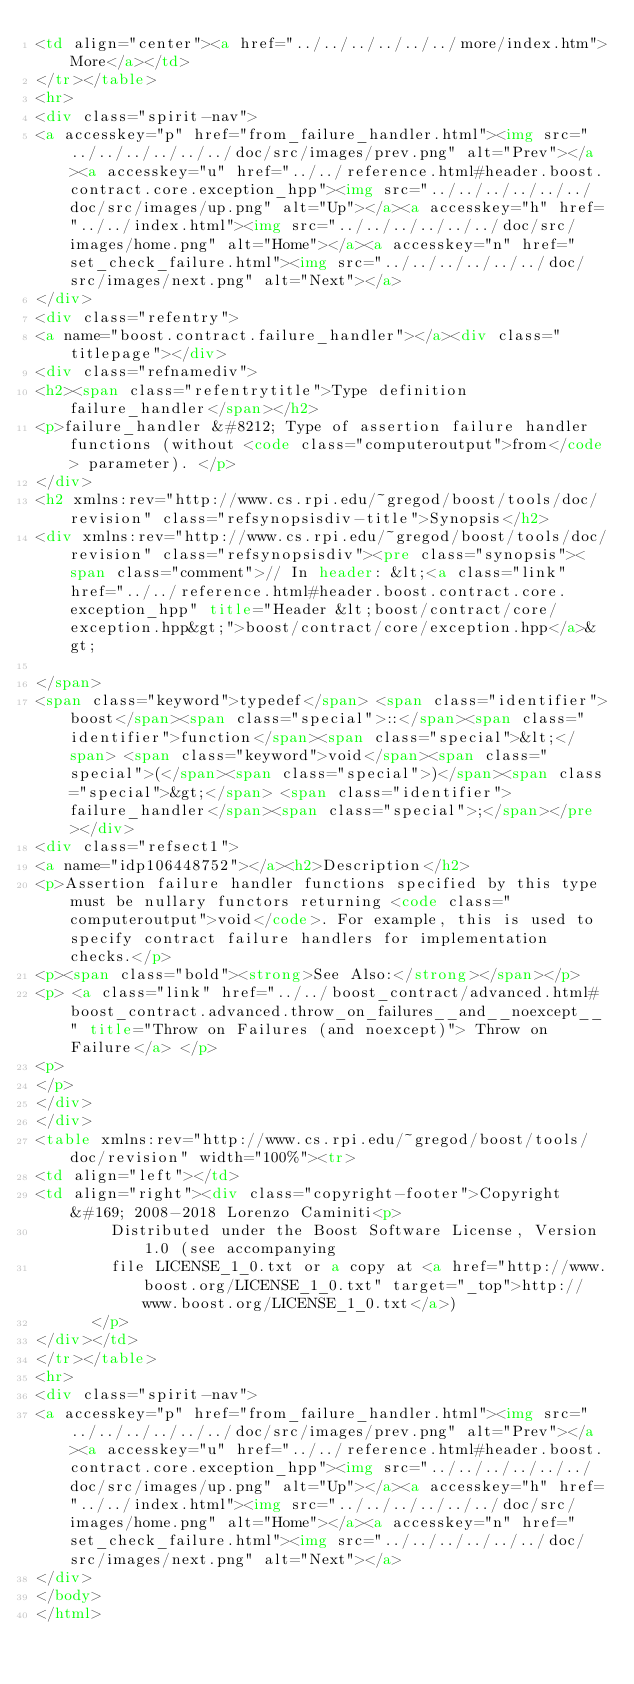Convert code to text. <code><loc_0><loc_0><loc_500><loc_500><_HTML_><td align="center"><a href="../../../../../../more/index.htm">More</a></td>
</tr></table>
<hr>
<div class="spirit-nav">
<a accesskey="p" href="from_failure_handler.html"><img src="../../../../../../doc/src/images/prev.png" alt="Prev"></a><a accesskey="u" href="../../reference.html#header.boost.contract.core.exception_hpp"><img src="../../../../../../doc/src/images/up.png" alt="Up"></a><a accesskey="h" href="../../index.html"><img src="../../../../../../doc/src/images/home.png" alt="Home"></a><a accesskey="n" href="set_check_failure.html"><img src="../../../../../../doc/src/images/next.png" alt="Next"></a>
</div>
<div class="refentry">
<a name="boost.contract.failure_handler"></a><div class="titlepage"></div>
<div class="refnamediv">
<h2><span class="refentrytitle">Type definition failure_handler</span></h2>
<p>failure_handler &#8212; Type of assertion failure handler functions (without <code class="computeroutput">from</code> parameter). </p>
</div>
<h2 xmlns:rev="http://www.cs.rpi.edu/~gregod/boost/tools/doc/revision" class="refsynopsisdiv-title">Synopsis</h2>
<div xmlns:rev="http://www.cs.rpi.edu/~gregod/boost/tools/doc/revision" class="refsynopsisdiv"><pre class="synopsis"><span class="comment">// In header: &lt;<a class="link" href="../../reference.html#header.boost.contract.core.exception_hpp" title="Header &lt;boost/contract/core/exception.hpp&gt;">boost/contract/core/exception.hpp</a>&gt;

</span>
<span class="keyword">typedef</span> <span class="identifier">boost</span><span class="special">::</span><span class="identifier">function</span><span class="special">&lt;</span> <span class="keyword">void</span><span class="special">(</span><span class="special">)</span><span class="special">&gt;</span> <span class="identifier">failure_handler</span><span class="special">;</span></pre></div>
<div class="refsect1">
<a name="idp106448752"></a><h2>Description</h2>
<p>Assertion failure handler functions specified by this type must be nullary functors returning <code class="computeroutput">void</code>. For example, this is used to specify contract failure handlers for implementation checks.</p>
<p><span class="bold"><strong>See Also:</strong></span></p>
<p> <a class="link" href="../../boost_contract/advanced.html#boost_contract.advanced.throw_on_failures__and__noexcept__" title="Throw on Failures (and noexcept)"> Throw on Failure</a> </p>
<p>
</p>
</div>
</div>
<table xmlns:rev="http://www.cs.rpi.edu/~gregod/boost/tools/doc/revision" width="100%"><tr>
<td align="left"></td>
<td align="right"><div class="copyright-footer">Copyright &#169; 2008-2018 Lorenzo Caminiti<p>
        Distributed under the Boost Software License, Version 1.0 (see accompanying
        file LICENSE_1_0.txt or a copy at <a href="http://www.boost.org/LICENSE_1_0.txt" target="_top">http://www.boost.org/LICENSE_1_0.txt</a>)
      </p>
</div></td>
</tr></table>
<hr>
<div class="spirit-nav">
<a accesskey="p" href="from_failure_handler.html"><img src="../../../../../../doc/src/images/prev.png" alt="Prev"></a><a accesskey="u" href="../../reference.html#header.boost.contract.core.exception_hpp"><img src="../../../../../../doc/src/images/up.png" alt="Up"></a><a accesskey="h" href="../../index.html"><img src="../../../../../../doc/src/images/home.png" alt="Home"></a><a accesskey="n" href="set_check_failure.html"><img src="../../../../../../doc/src/images/next.png" alt="Next"></a>
</div>
</body>
</html>
</code> 